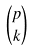<formula> <loc_0><loc_0><loc_500><loc_500>\binom { p } { k }</formula> 